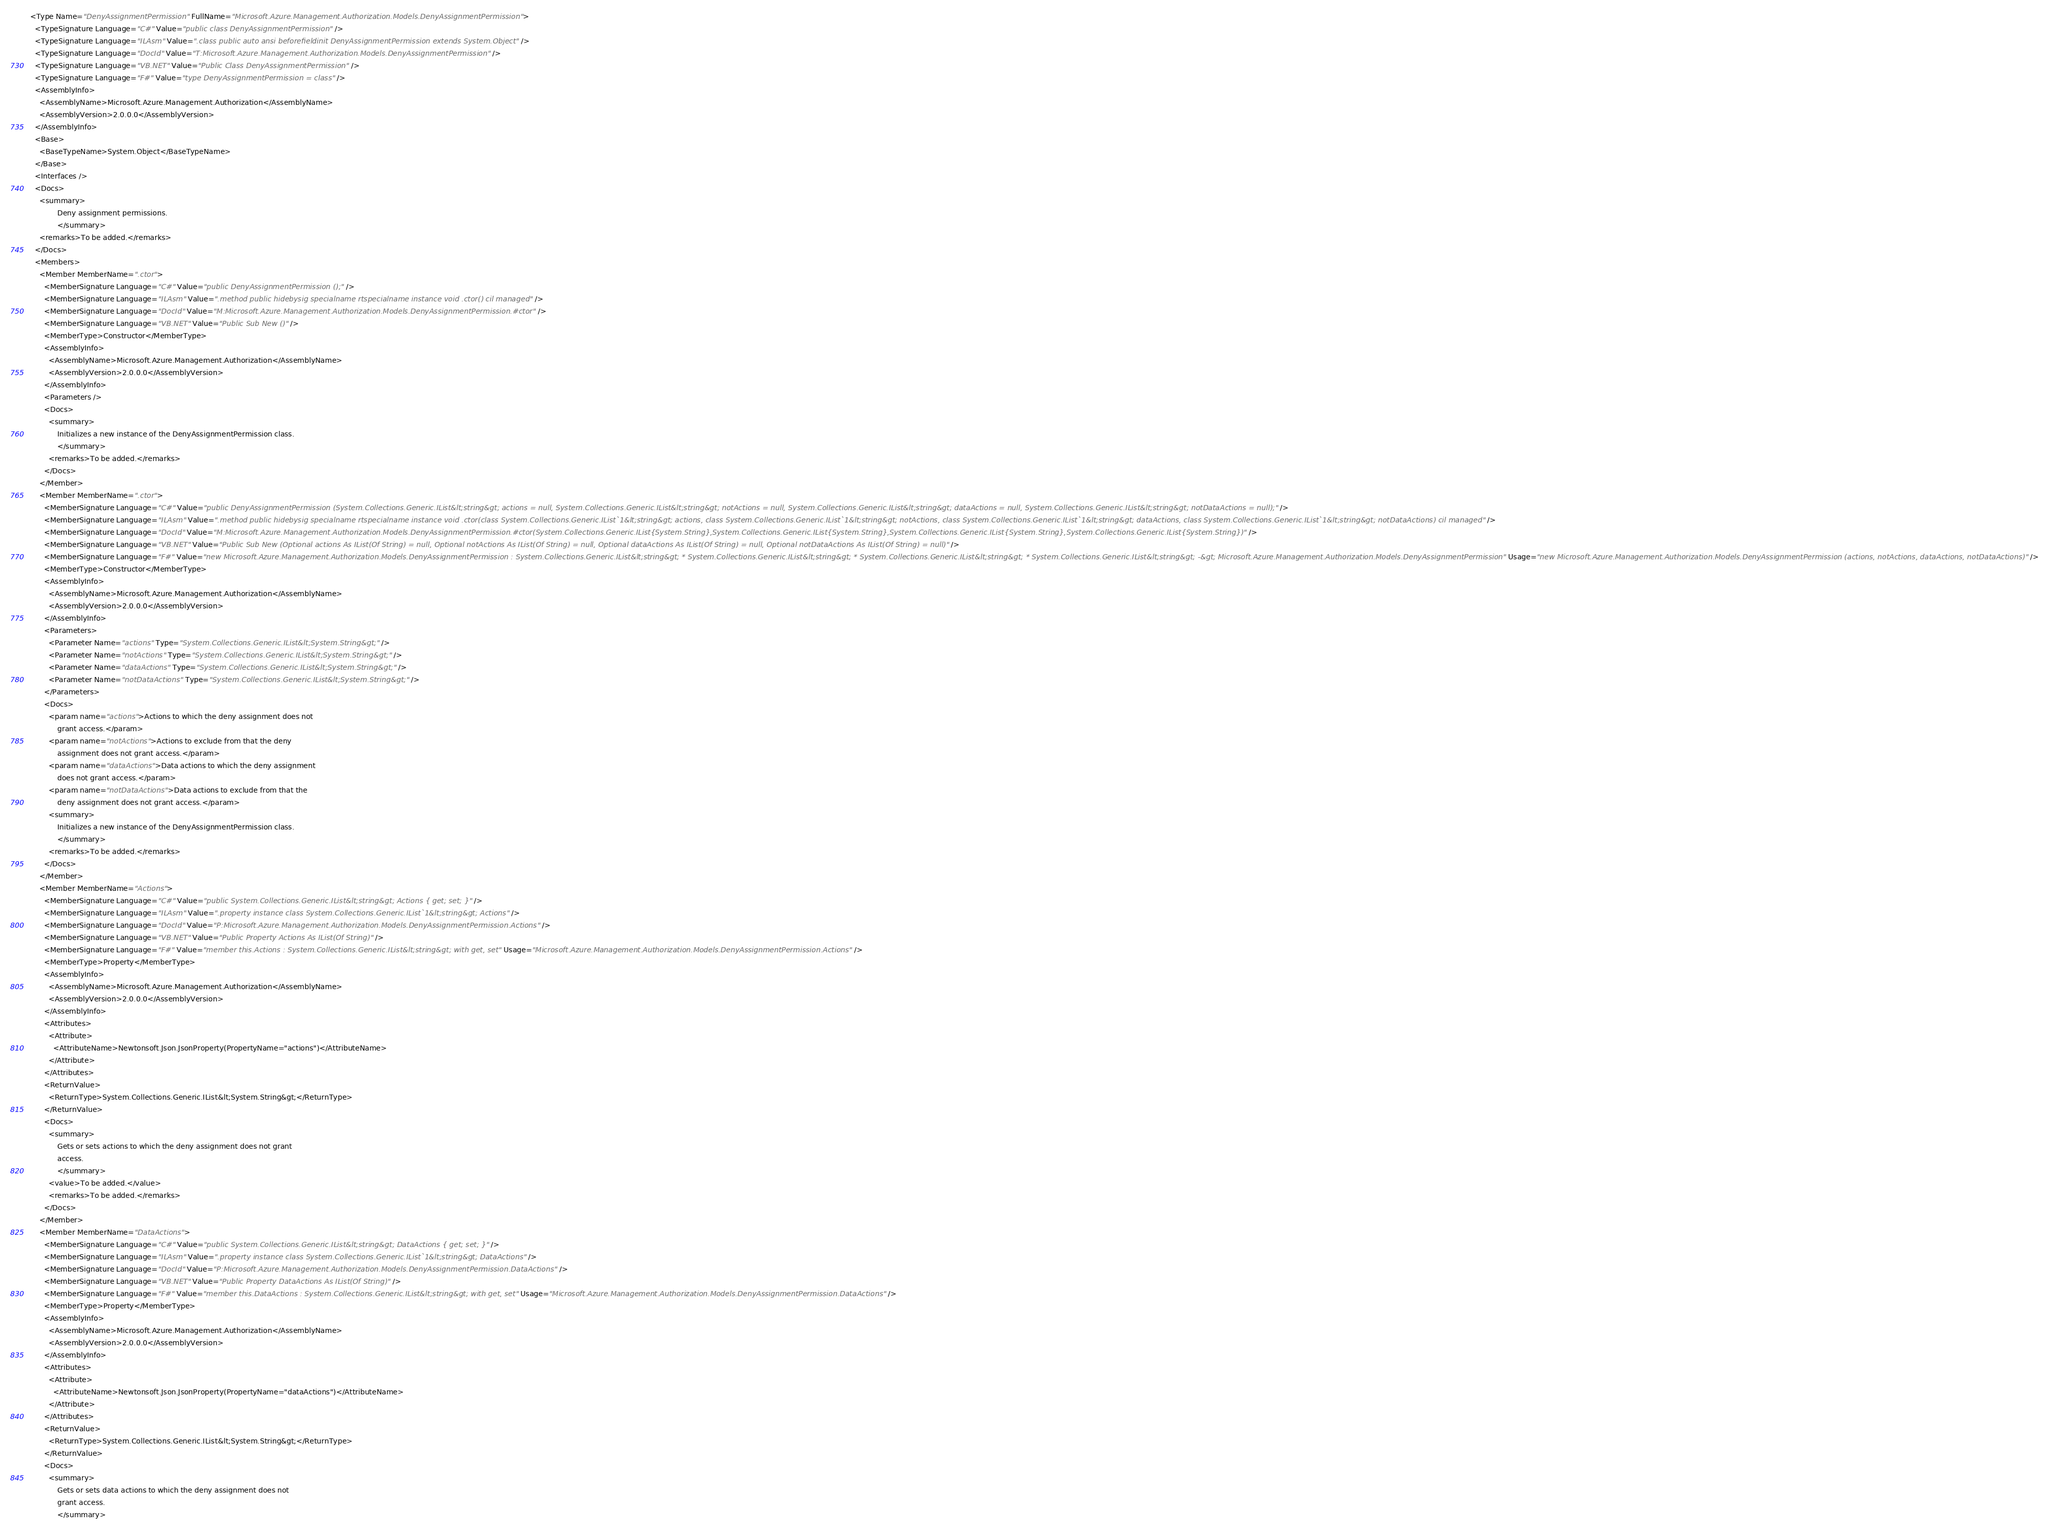Convert code to text. <code><loc_0><loc_0><loc_500><loc_500><_XML_><Type Name="DenyAssignmentPermission" FullName="Microsoft.Azure.Management.Authorization.Models.DenyAssignmentPermission">
  <TypeSignature Language="C#" Value="public class DenyAssignmentPermission" />
  <TypeSignature Language="ILAsm" Value=".class public auto ansi beforefieldinit DenyAssignmentPermission extends System.Object" />
  <TypeSignature Language="DocId" Value="T:Microsoft.Azure.Management.Authorization.Models.DenyAssignmentPermission" />
  <TypeSignature Language="VB.NET" Value="Public Class DenyAssignmentPermission" />
  <TypeSignature Language="F#" Value="type DenyAssignmentPermission = class" />
  <AssemblyInfo>
    <AssemblyName>Microsoft.Azure.Management.Authorization</AssemblyName>
    <AssemblyVersion>2.0.0.0</AssemblyVersion>
  </AssemblyInfo>
  <Base>
    <BaseTypeName>System.Object</BaseTypeName>
  </Base>
  <Interfaces />
  <Docs>
    <summary>
            Deny assignment permissions.
            </summary>
    <remarks>To be added.</remarks>
  </Docs>
  <Members>
    <Member MemberName=".ctor">
      <MemberSignature Language="C#" Value="public DenyAssignmentPermission ();" />
      <MemberSignature Language="ILAsm" Value=".method public hidebysig specialname rtspecialname instance void .ctor() cil managed" />
      <MemberSignature Language="DocId" Value="M:Microsoft.Azure.Management.Authorization.Models.DenyAssignmentPermission.#ctor" />
      <MemberSignature Language="VB.NET" Value="Public Sub New ()" />
      <MemberType>Constructor</MemberType>
      <AssemblyInfo>
        <AssemblyName>Microsoft.Azure.Management.Authorization</AssemblyName>
        <AssemblyVersion>2.0.0.0</AssemblyVersion>
      </AssemblyInfo>
      <Parameters />
      <Docs>
        <summary>
            Initializes a new instance of the DenyAssignmentPermission class.
            </summary>
        <remarks>To be added.</remarks>
      </Docs>
    </Member>
    <Member MemberName=".ctor">
      <MemberSignature Language="C#" Value="public DenyAssignmentPermission (System.Collections.Generic.IList&lt;string&gt; actions = null, System.Collections.Generic.IList&lt;string&gt; notActions = null, System.Collections.Generic.IList&lt;string&gt; dataActions = null, System.Collections.Generic.IList&lt;string&gt; notDataActions = null);" />
      <MemberSignature Language="ILAsm" Value=".method public hidebysig specialname rtspecialname instance void .ctor(class System.Collections.Generic.IList`1&lt;string&gt; actions, class System.Collections.Generic.IList`1&lt;string&gt; notActions, class System.Collections.Generic.IList`1&lt;string&gt; dataActions, class System.Collections.Generic.IList`1&lt;string&gt; notDataActions) cil managed" />
      <MemberSignature Language="DocId" Value="M:Microsoft.Azure.Management.Authorization.Models.DenyAssignmentPermission.#ctor(System.Collections.Generic.IList{System.String},System.Collections.Generic.IList{System.String},System.Collections.Generic.IList{System.String},System.Collections.Generic.IList{System.String})" />
      <MemberSignature Language="VB.NET" Value="Public Sub New (Optional actions As IList(Of String) = null, Optional notActions As IList(Of String) = null, Optional dataActions As IList(Of String) = null, Optional notDataActions As IList(Of String) = null)" />
      <MemberSignature Language="F#" Value="new Microsoft.Azure.Management.Authorization.Models.DenyAssignmentPermission : System.Collections.Generic.IList&lt;string&gt; * System.Collections.Generic.IList&lt;string&gt; * System.Collections.Generic.IList&lt;string&gt; * System.Collections.Generic.IList&lt;string&gt; -&gt; Microsoft.Azure.Management.Authorization.Models.DenyAssignmentPermission" Usage="new Microsoft.Azure.Management.Authorization.Models.DenyAssignmentPermission (actions, notActions, dataActions, notDataActions)" />
      <MemberType>Constructor</MemberType>
      <AssemblyInfo>
        <AssemblyName>Microsoft.Azure.Management.Authorization</AssemblyName>
        <AssemblyVersion>2.0.0.0</AssemblyVersion>
      </AssemblyInfo>
      <Parameters>
        <Parameter Name="actions" Type="System.Collections.Generic.IList&lt;System.String&gt;" />
        <Parameter Name="notActions" Type="System.Collections.Generic.IList&lt;System.String&gt;" />
        <Parameter Name="dataActions" Type="System.Collections.Generic.IList&lt;System.String&gt;" />
        <Parameter Name="notDataActions" Type="System.Collections.Generic.IList&lt;System.String&gt;" />
      </Parameters>
      <Docs>
        <param name="actions">Actions to which the deny assignment does not
            grant access.</param>
        <param name="notActions">Actions to exclude from that the deny
            assignment does not grant access.</param>
        <param name="dataActions">Data actions to which the deny assignment
            does not grant access.</param>
        <param name="notDataActions">Data actions to exclude from that the
            deny assignment does not grant access.</param>
        <summary>
            Initializes a new instance of the DenyAssignmentPermission class.
            </summary>
        <remarks>To be added.</remarks>
      </Docs>
    </Member>
    <Member MemberName="Actions">
      <MemberSignature Language="C#" Value="public System.Collections.Generic.IList&lt;string&gt; Actions { get; set; }" />
      <MemberSignature Language="ILAsm" Value=".property instance class System.Collections.Generic.IList`1&lt;string&gt; Actions" />
      <MemberSignature Language="DocId" Value="P:Microsoft.Azure.Management.Authorization.Models.DenyAssignmentPermission.Actions" />
      <MemberSignature Language="VB.NET" Value="Public Property Actions As IList(Of String)" />
      <MemberSignature Language="F#" Value="member this.Actions : System.Collections.Generic.IList&lt;string&gt; with get, set" Usage="Microsoft.Azure.Management.Authorization.Models.DenyAssignmentPermission.Actions" />
      <MemberType>Property</MemberType>
      <AssemblyInfo>
        <AssemblyName>Microsoft.Azure.Management.Authorization</AssemblyName>
        <AssemblyVersion>2.0.0.0</AssemblyVersion>
      </AssemblyInfo>
      <Attributes>
        <Attribute>
          <AttributeName>Newtonsoft.Json.JsonProperty(PropertyName="actions")</AttributeName>
        </Attribute>
      </Attributes>
      <ReturnValue>
        <ReturnType>System.Collections.Generic.IList&lt;System.String&gt;</ReturnType>
      </ReturnValue>
      <Docs>
        <summary>
            Gets or sets actions to which the deny assignment does not grant
            access.
            </summary>
        <value>To be added.</value>
        <remarks>To be added.</remarks>
      </Docs>
    </Member>
    <Member MemberName="DataActions">
      <MemberSignature Language="C#" Value="public System.Collections.Generic.IList&lt;string&gt; DataActions { get; set; }" />
      <MemberSignature Language="ILAsm" Value=".property instance class System.Collections.Generic.IList`1&lt;string&gt; DataActions" />
      <MemberSignature Language="DocId" Value="P:Microsoft.Azure.Management.Authorization.Models.DenyAssignmentPermission.DataActions" />
      <MemberSignature Language="VB.NET" Value="Public Property DataActions As IList(Of String)" />
      <MemberSignature Language="F#" Value="member this.DataActions : System.Collections.Generic.IList&lt;string&gt; with get, set" Usage="Microsoft.Azure.Management.Authorization.Models.DenyAssignmentPermission.DataActions" />
      <MemberType>Property</MemberType>
      <AssemblyInfo>
        <AssemblyName>Microsoft.Azure.Management.Authorization</AssemblyName>
        <AssemblyVersion>2.0.0.0</AssemblyVersion>
      </AssemblyInfo>
      <Attributes>
        <Attribute>
          <AttributeName>Newtonsoft.Json.JsonProperty(PropertyName="dataActions")</AttributeName>
        </Attribute>
      </Attributes>
      <ReturnValue>
        <ReturnType>System.Collections.Generic.IList&lt;System.String&gt;</ReturnType>
      </ReturnValue>
      <Docs>
        <summary>
            Gets or sets data actions to which the deny assignment does not
            grant access.
            </summary></code> 